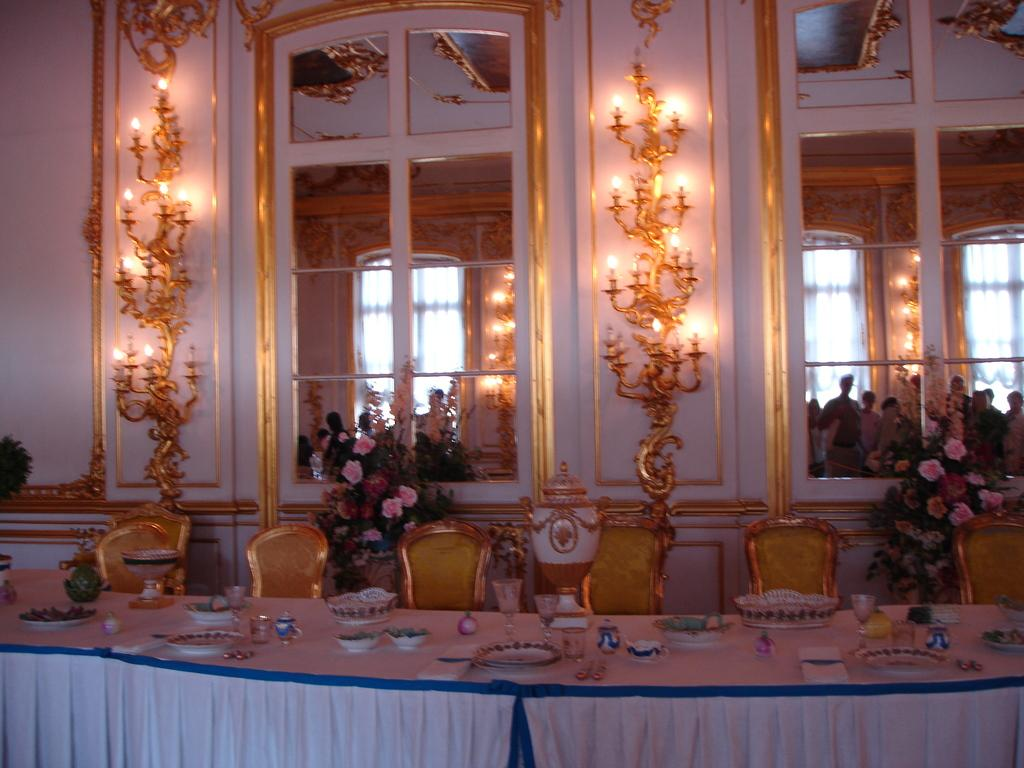What type of furniture is in the center of the image? There is a big dining table in the image. What items can be seen on the dining table? There are plates and wine glasses on the dining table. How many chairs are around the dining table? There are chairs around the dining table. What architectural features can be seen in the image? There are two glass windows in the image. What type of lighting is present in the image? There are lights on the wall in the image. How many balls are visible on the secretary in the image? There is no secretary or balls present in the image. 